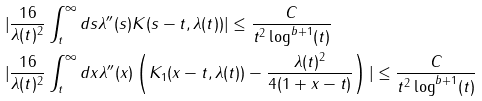<formula> <loc_0><loc_0><loc_500><loc_500>& | \frac { 1 6 } { \lambda ( t ) ^ { 2 } } \int _ { t } ^ { \infty } d s \lambda ^ { \prime \prime } ( s ) K ( s - t , \lambda ( t ) ) | \leq \frac { C } { t ^ { 2 } \log ^ { b + 1 } ( t ) } \\ & | \frac { 1 6 } { \lambda ( t ) ^ { 2 } } \int _ { t } ^ { \infty } d x \lambda ^ { \prime \prime } ( x ) \left ( K _ { 1 } ( x - t , \lambda ( t ) ) - \frac { \lambda ( t ) ^ { 2 } } { 4 ( 1 + x - t ) } \right ) | \leq \frac { C } { t ^ { 2 } \log ^ { b + 1 } ( t ) }</formula> 